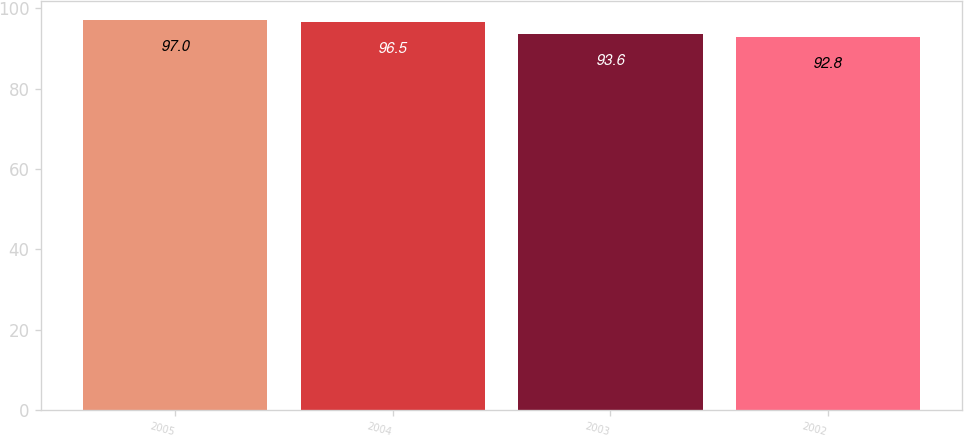Convert chart. <chart><loc_0><loc_0><loc_500><loc_500><bar_chart><fcel>2005<fcel>2004<fcel>2003<fcel>2002<nl><fcel>97<fcel>96.5<fcel>93.6<fcel>92.8<nl></chart> 